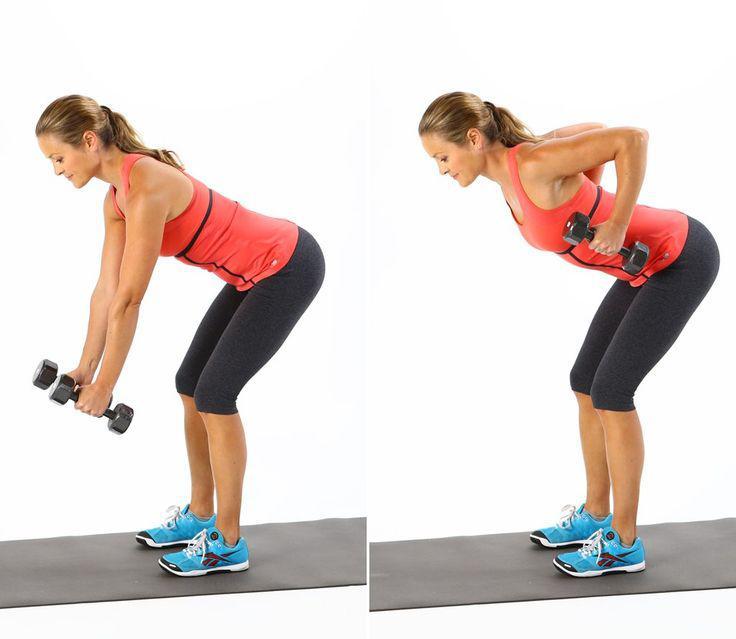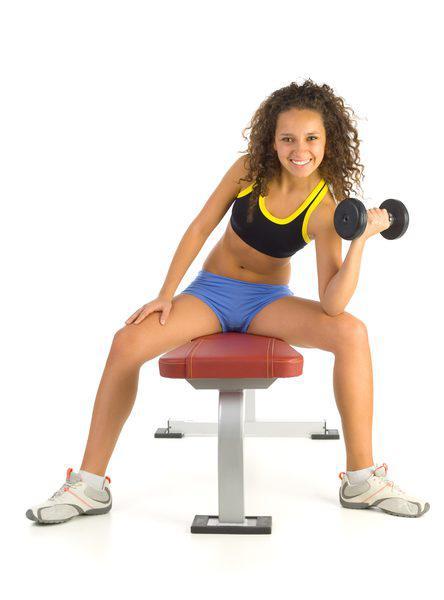The first image is the image on the left, the second image is the image on the right. Assess this claim about the two images: "One of the images contains a woman sitting on fitness equipment.". Correct or not? Answer yes or no. Yes. 